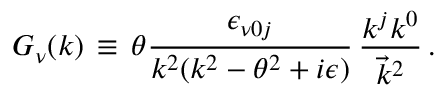<formula> <loc_0><loc_0><loc_500><loc_500>G _ { \nu } ( k ) \, \equiv \, \theta \frac { \epsilon _ { \nu 0 j } } { k ^ { 2 } ( k ^ { 2 } - \theta ^ { 2 } + i \epsilon ) } \, \frac { k ^ { j } k ^ { 0 } } { { \vec { k } } ^ { 2 } } \, .</formula> 